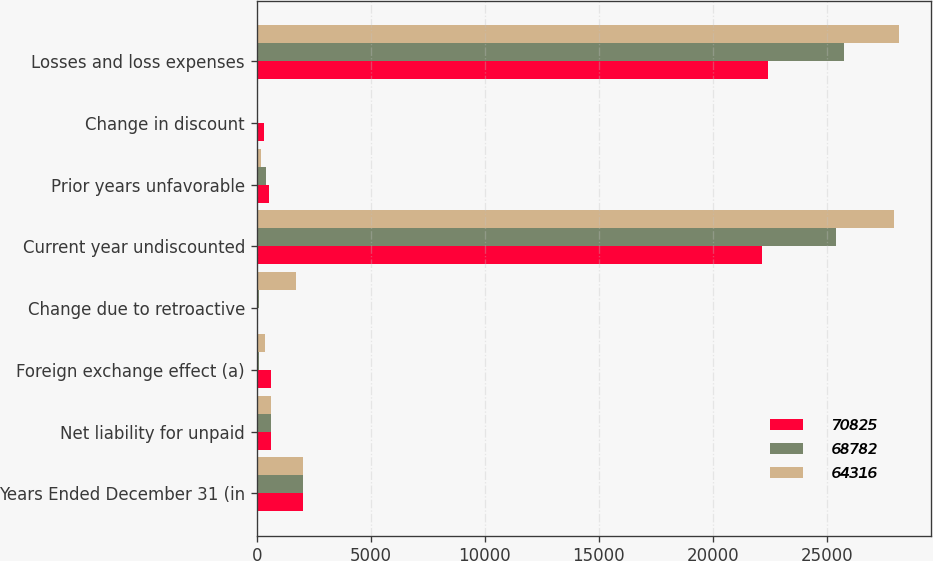Convert chart. <chart><loc_0><loc_0><loc_500><loc_500><stacked_bar_chart><ecel><fcel>Years Ended December 31 (in<fcel>Net liability for unpaid<fcel>Foreign exchange effect (a)<fcel>Change due to retroactive<fcel>Current year undiscounted<fcel>Prior years unfavorable<fcel>Change in discount<fcel>Losses and loss expenses<nl><fcel>70825<fcel>2013<fcel>617<fcel>617<fcel>22<fcel>22171<fcel>557<fcel>309<fcel>22419<nl><fcel>68782<fcel>2012<fcel>617<fcel>90<fcel>90<fcel>25385<fcel>421<fcel>63<fcel>25743<nl><fcel>64316<fcel>2011<fcel>617<fcel>353<fcel>1703<fcel>27931<fcel>195<fcel>34<fcel>28160<nl></chart> 